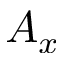<formula> <loc_0><loc_0><loc_500><loc_500>A _ { x }</formula> 